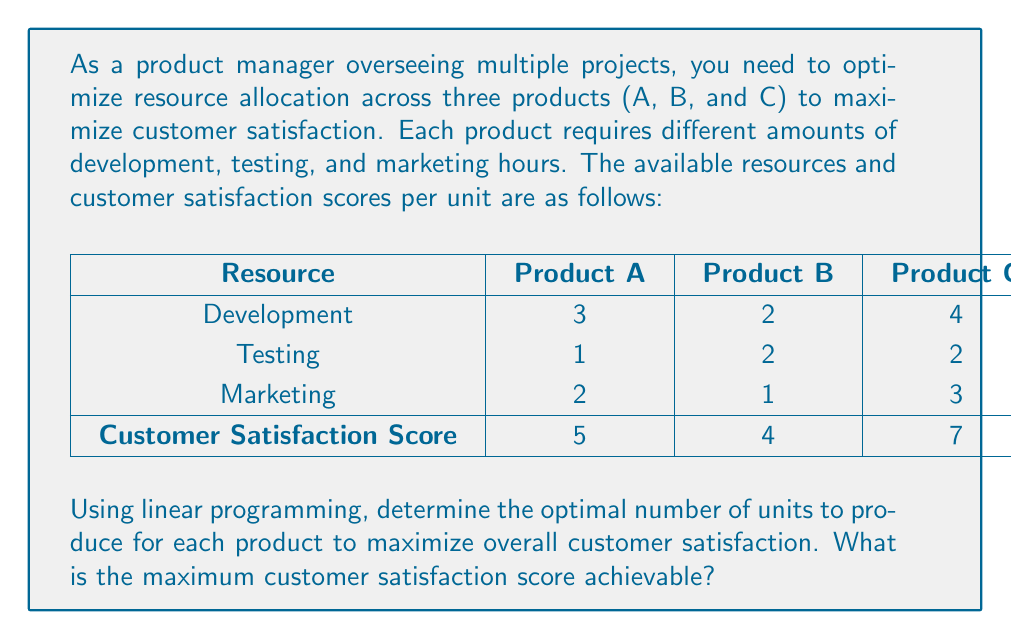Could you help me with this problem? To solve this linear programming problem, we'll follow these steps:

1. Define variables:
   Let $x$, $y$, and $z$ be the number of units produced for Products A, B, and C respectively.

2. Set up the objective function:
   Maximize $Z = 5x + 4y + 7z$ (customer satisfaction score)

3. Define constraints:
   Development: $3x + 2y + 4z \leq 300$
   Testing: $x + 2y + 2z \leq 180$
   Marketing: $2x + y + 3z \leq 240$
   Non-negativity: $x, y, z \geq 0$

4. Solve using the simplex method or a linear programming solver:
   
   Using a solver, we get the optimal solution:
   $x = 60$ (Product A)
   $y = 30$ (Product B)
   $z = 30$ (Product C)

5. Calculate the maximum customer satisfaction score:
   $Z = 5(60) + 4(30) + 7(30) = 300 + 120 + 210 = 630$

6. Verify constraints:
   Development: $3(60) + 2(30) + 4(30) = 300 \leq 300$
   Testing: $60 + 2(30) + 2(30) = 180 \leq 180$
   Marketing: $2(60) + 30 + 3(30) = 240 \leq 240$

The solution satisfies all constraints and maximizes the customer satisfaction score.
Answer: 630 